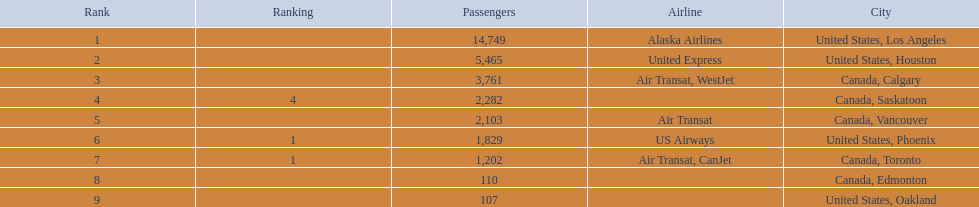What are the cities that are associated with the playa de oro international airport? United States, Los Angeles, United States, Houston, Canada, Calgary, Canada, Saskatoon, Canada, Vancouver, United States, Phoenix, Canada, Toronto, Canada, Edmonton, United States, Oakland. What is uniteed states, los angeles passenger count? 14,749. What other cities passenger count would lead to 19,000 roughly when combined with previous los angeles? Canada, Calgary. 